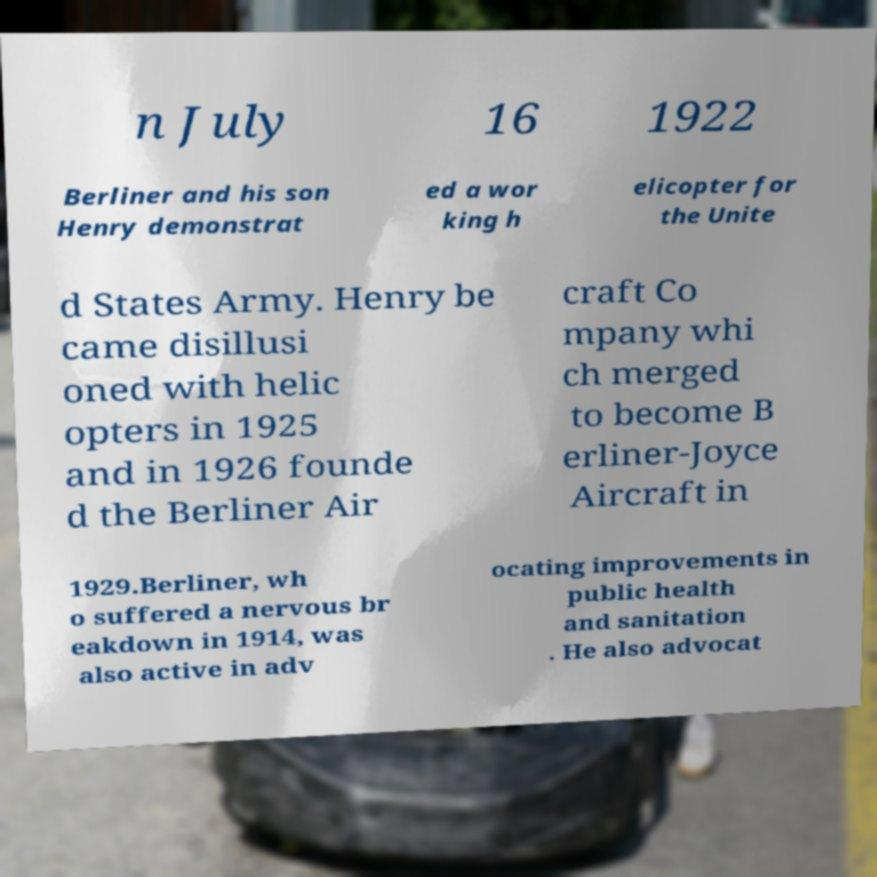Can you accurately transcribe the text from the provided image for me? n July 16 1922 Berliner and his son Henry demonstrat ed a wor king h elicopter for the Unite d States Army. Henry be came disillusi oned with helic opters in 1925 and in 1926 founde d the Berliner Air craft Co mpany whi ch merged to become B erliner-Joyce Aircraft in 1929.Berliner, wh o suffered a nervous br eakdown in 1914, was also active in adv ocating improvements in public health and sanitation . He also advocat 